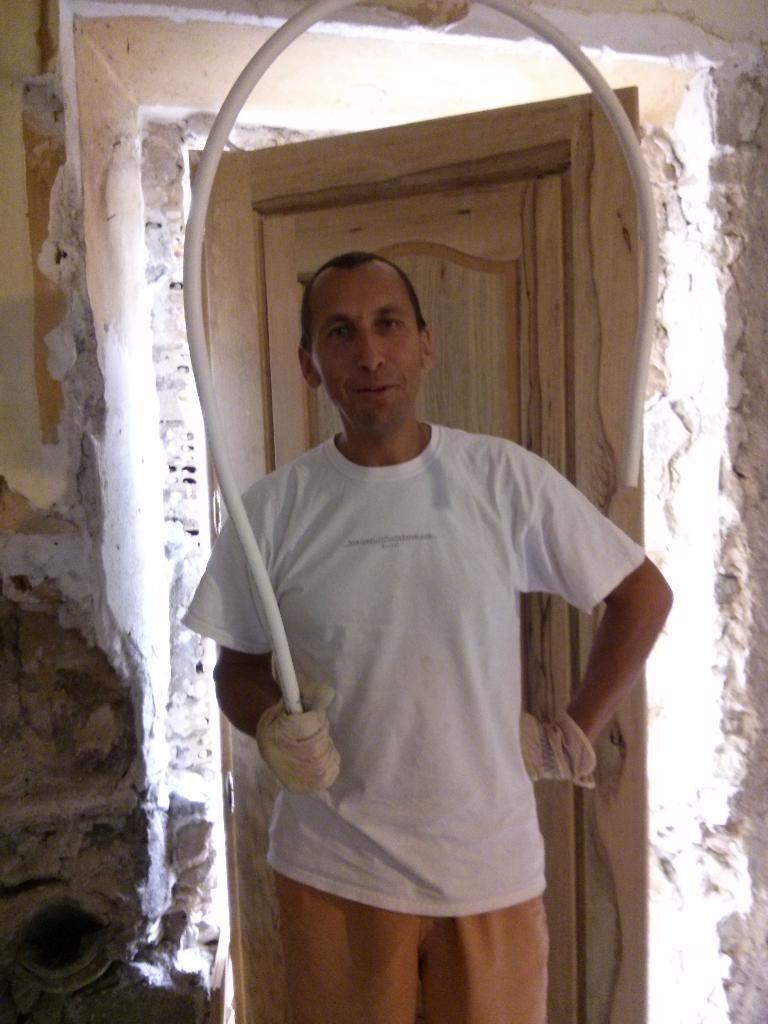What is the main subject in the foreground of the image? There is a man standing in the foreground of the image. What is the man wearing on his hands? The man is wearing gloves. What object is the man holding in the image? The man is holding a u-shaped pipe-like object. What type of structure can be seen in the background of the image? There is a wooden door in the background of the image. What type of surface is visible behind the man? There is a wall visible in the background of the image. Where is the playground located in the image? There is no playground present in the image. --- Facts: 1. There is a person in the image. 2. The person is wearing a hat. 3. The person is holding a book. 4. There is a wooden table in the image. 5. There is a wooden chair in the image. Absurd Topics: robot, robot Conversation: Who or what is the main subject in the image? There is a person in the image. What is the person wearing on their head? The person is wearing a hat. What object is the person holding in the image? The person is holding a book. What type of furniture is visible in the image? There is a wooden table in the image. What type of seating is visible in the image? There is a wooden chair in the image. Reasoning: Let's think step by step in order to produce the conversation. We start by identifying the main subject in the image, which is the person. Next, we describe specific details about the person, such as the hat they are wearing. Then, we observe the object the person is holding, which is a book. After that, we describe the type of furniture visible in the image, which is a wooden table. Finally, we describe the type of seating visible in the image, which is a wooden chair. Absurd Question/Answer: Where is the robot located in the image? There is no robot present in the image. 